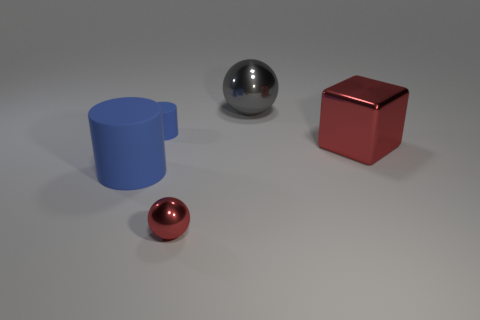There is a cylinder that is the same color as the big matte object; what is its size?
Give a very brief answer. Small. What number of big gray things are to the left of the red metallic object that is to the right of the ball to the right of the tiny red sphere?
Provide a short and direct response. 1. Does the large matte thing have the same color as the large metal sphere?
Offer a terse response. No. Is there a big shiny sphere of the same color as the small matte cylinder?
Give a very brief answer. No. There is a matte object that is the same size as the red sphere; what color is it?
Your response must be concise. Blue. Are there any other big metal objects of the same shape as the gray object?
Offer a terse response. No. There is a tiny object that is the same color as the cube; what shape is it?
Your answer should be compact. Sphere. Is there a small red ball to the right of the cube that is right of the red shiny thing that is left of the large gray metal thing?
Provide a succinct answer. No. The blue matte thing that is the same size as the gray thing is what shape?
Ensure brevity in your answer.  Cylinder. What is the color of the big object that is the same shape as the small metallic object?
Offer a terse response. Gray. 